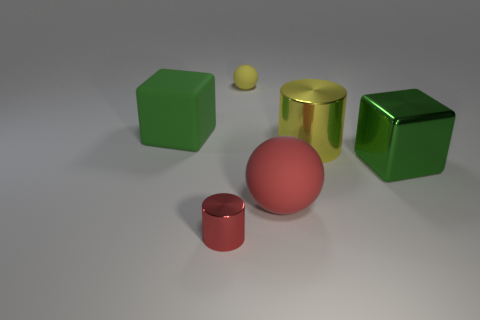Are there any other things that have the same shape as the tiny red object?
Offer a terse response. Yes. Are there more yellow balls on the left side of the tiny yellow object than yellow matte things that are in front of the green rubber thing?
Make the answer very short. No. There is a large matte thing that is behind the large matte ball; what number of balls are behind it?
Give a very brief answer. 1. How many things are either big blue matte balls or small yellow things?
Ensure brevity in your answer.  1. Is the tiny red thing the same shape as the large yellow metallic object?
Your answer should be compact. Yes. What is the small red thing made of?
Offer a terse response. Metal. How many cylinders are both on the left side of the large yellow metal thing and on the right side of the tiny yellow object?
Give a very brief answer. 0. Is the green shiny thing the same size as the red ball?
Make the answer very short. Yes. There is a yellow thing in front of the yellow ball; is its size the same as the tiny ball?
Ensure brevity in your answer.  No. What color is the small object on the left side of the yellow sphere?
Ensure brevity in your answer.  Red. 